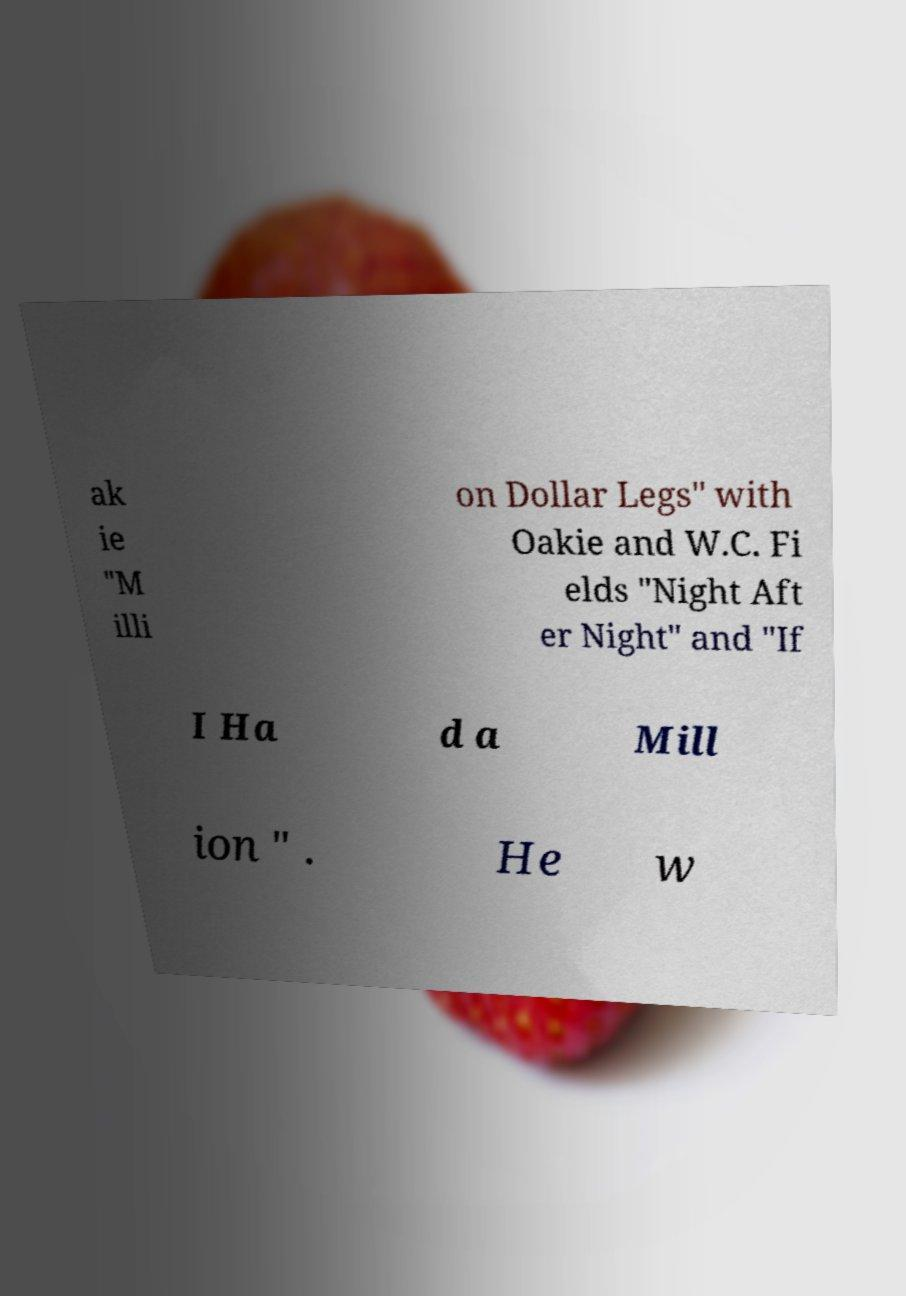There's text embedded in this image that I need extracted. Can you transcribe it verbatim? ak ie "M illi on Dollar Legs" with Oakie and W.C. Fi elds "Night Aft er Night" and "If I Ha d a Mill ion " . He w 